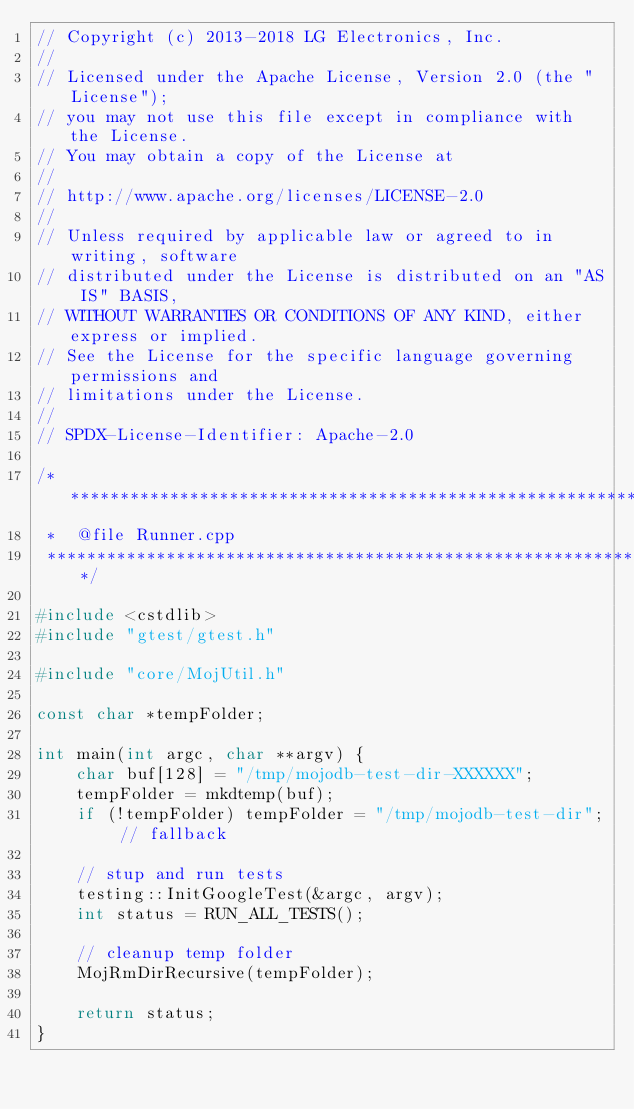<code> <loc_0><loc_0><loc_500><loc_500><_C++_>// Copyright (c) 2013-2018 LG Electronics, Inc.
//
// Licensed under the Apache License, Version 2.0 (the "License");
// you may not use this file except in compliance with the License.
// You may obtain a copy of the License at
//
// http://www.apache.org/licenses/LICENSE-2.0
//
// Unless required by applicable law or agreed to in writing, software
// distributed under the License is distributed on an "AS IS" BASIS,
// WITHOUT WARRANTIES OR CONDITIONS OF ANY KIND, either express or implied.
// See the License for the specific language governing permissions and
// limitations under the License.
//
// SPDX-License-Identifier: Apache-2.0

/****************************************************************
 *  @file Runner.cpp
 ****************************************************************/

#include <cstdlib>
#include "gtest/gtest.h"

#include "core/MojUtil.h"

const char *tempFolder;

int main(int argc, char **argv) {
    char buf[128] = "/tmp/mojodb-test-dir-XXXXXX";
    tempFolder = mkdtemp(buf);
    if (!tempFolder) tempFolder = "/tmp/mojodb-test-dir"; // fallback

    // stup and run tests
    testing::InitGoogleTest(&argc, argv);
    int status = RUN_ALL_TESTS();

    // cleanup temp folder
    MojRmDirRecursive(tempFolder);

    return status;
}
</code> 